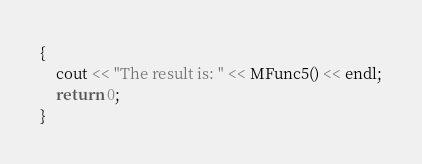Convert code to text. <code><loc_0><loc_0><loc_500><loc_500><_C++_>{
	cout << "The result is: " << MFunc5() << endl;
	return 0;
}</code> 